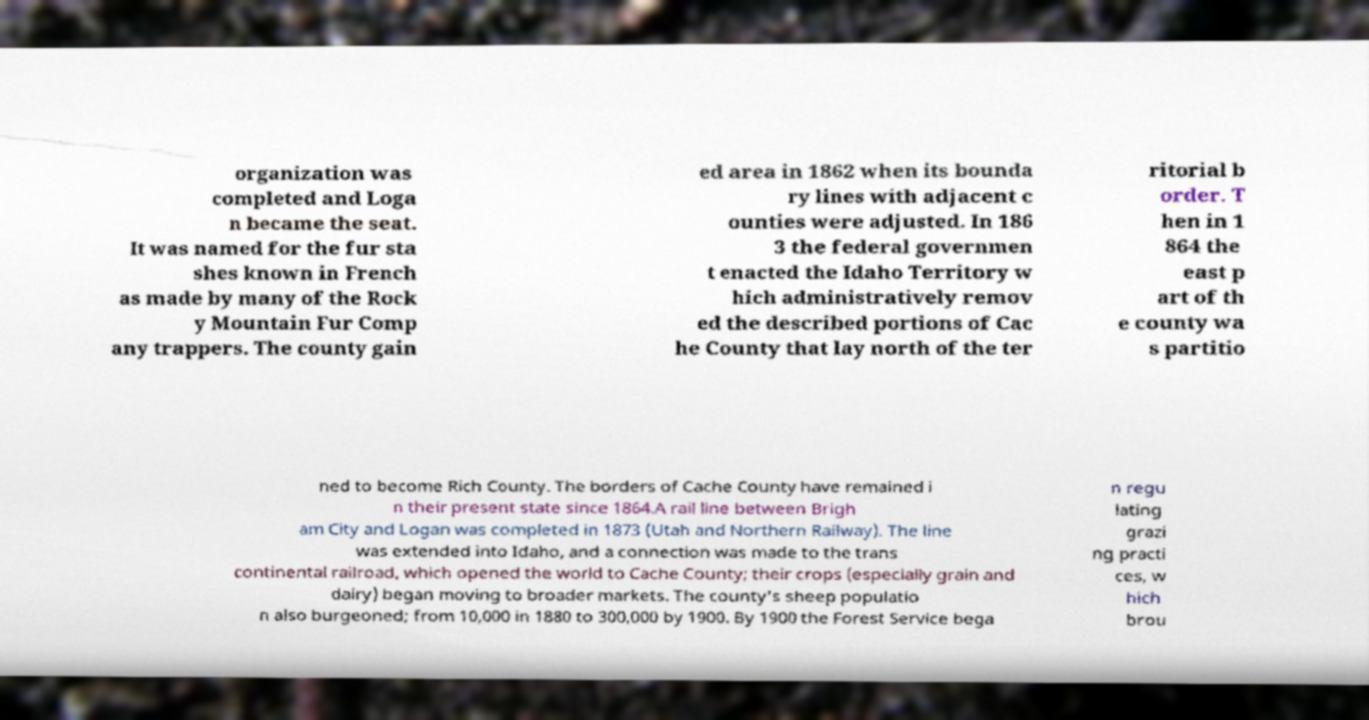I need the written content from this picture converted into text. Can you do that? organization was completed and Loga n became the seat. It was named for the fur sta shes known in French as made by many of the Rock y Mountain Fur Comp any trappers. The county gain ed area in 1862 when its bounda ry lines with adjacent c ounties were adjusted. In 186 3 the federal governmen t enacted the Idaho Territory w hich administratively remov ed the described portions of Cac he County that lay north of the ter ritorial b order. T hen in 1 864 the east p art of th e county wa s partitio ned to become Rich County. The borders of Cache County have remained i n their present state since 1864.A rail line between Brigh am City and Logan was completed in 1873 (Utah and Northern Railway). The line was extended into Idaho, and a connection was made to the trans continental railroad, which opened the world to Cache County; their crops (especially grain and dairy) began moving to broader markets. The county's sheep populatio n also burgeoned; from 10,000 in 1880 to 300,000 by 1900. By 1900 the Forest Service bega n regu lating grazi ng practi ces, w hich brou 